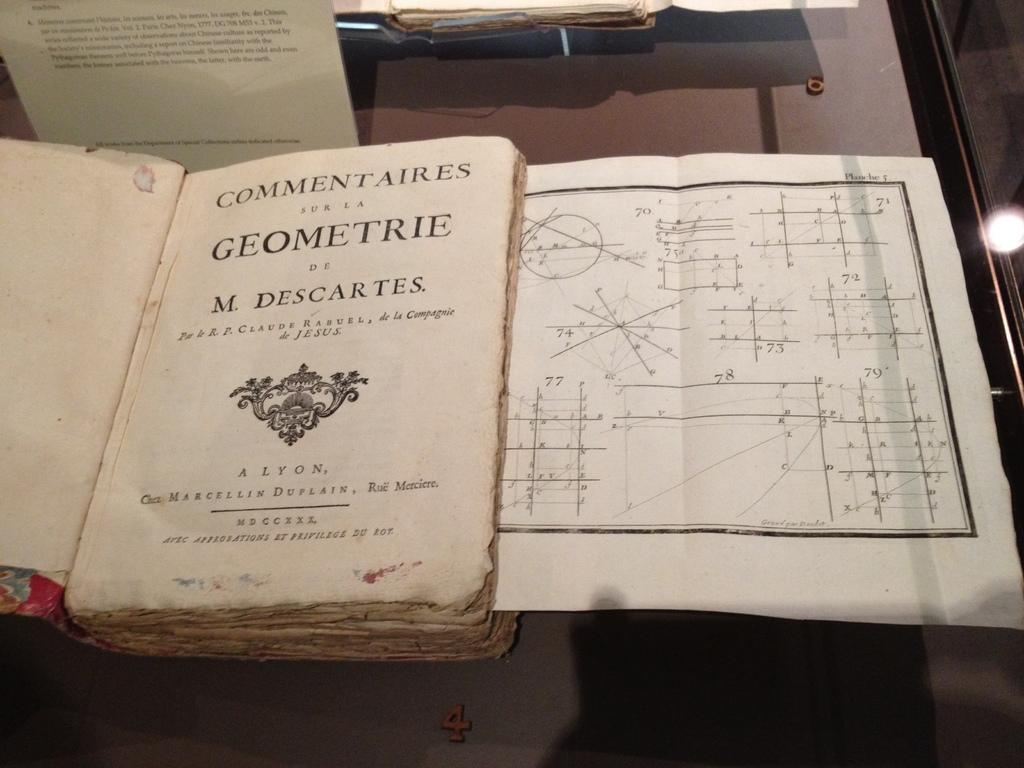<image>
Provide a brief description of the given image. Open book that is about Commentaries sur la geomerie 